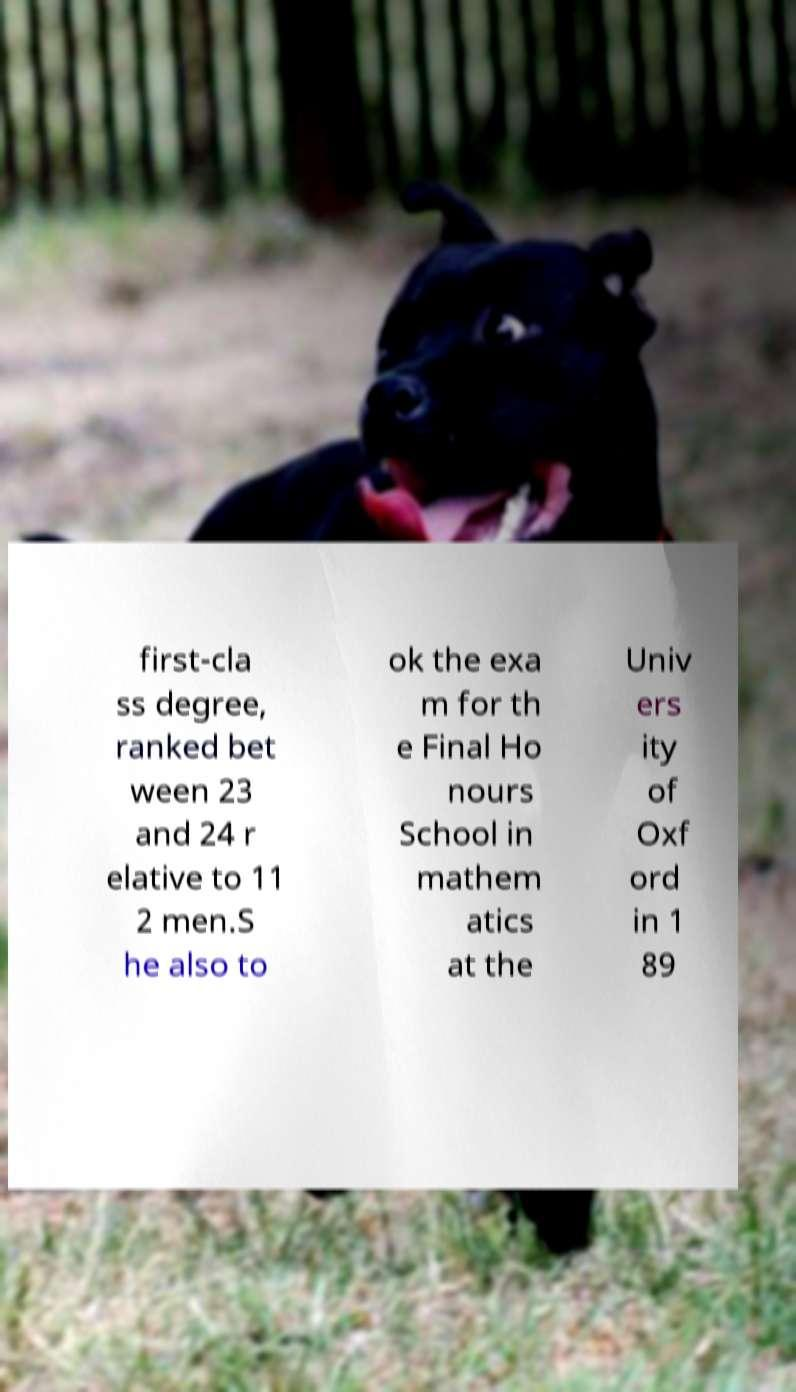What messages or text are displayed in this image? I need them in a readable, typed format. first-cla ss degree, ranked bet ween 23 and 24 r elative to 11 2 men.S he also to ok the exa m for th e Final Ho nours School in mathem atics at the Univ ers ity of Oxf ord in 1 89 